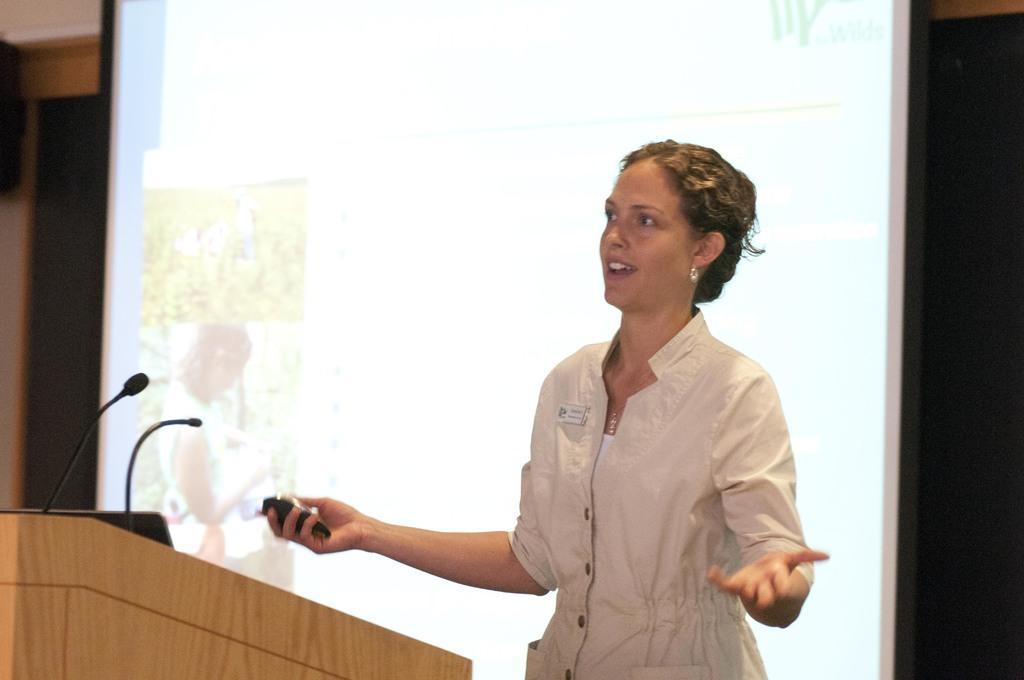In one or two sentences, can you explain what this image depicts? In this image we can see a projector screen. There is a podium in the image. A lady is standing and holding some object in her hand. There is an object on a wall at the left side of the image. 